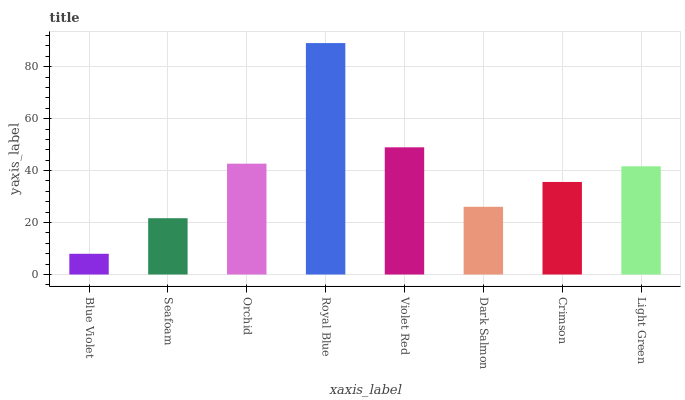Is Blue Violet the minimum?
Answer yes or no. Yes. Is Royal Blue the maximum?
Answer yes or no. Yes. Is Seafoam the minimum?
Answer yes or no. No. Is Seafoam the maximum?
Answer yes or no. No. Is Seafoam greater than Blue Violet?
Answer yes or no. Yes. Is Blue Violet less than Seafoam?
Answer yes or no. Yes. Is Blue Violet greater than Seafoam?
Answer yes or no. No. Is Seafoam less than Blue Violet?
Answer yes or no. No. Is Light Green the high median?
Answer yes or no. Yes. Is Crimson the low median?
Answer yes or no. Yes. Is Royal Blue the high median?
Answer yes or no. No. Is Violet Red the low median?
Answer yes or no. No. 